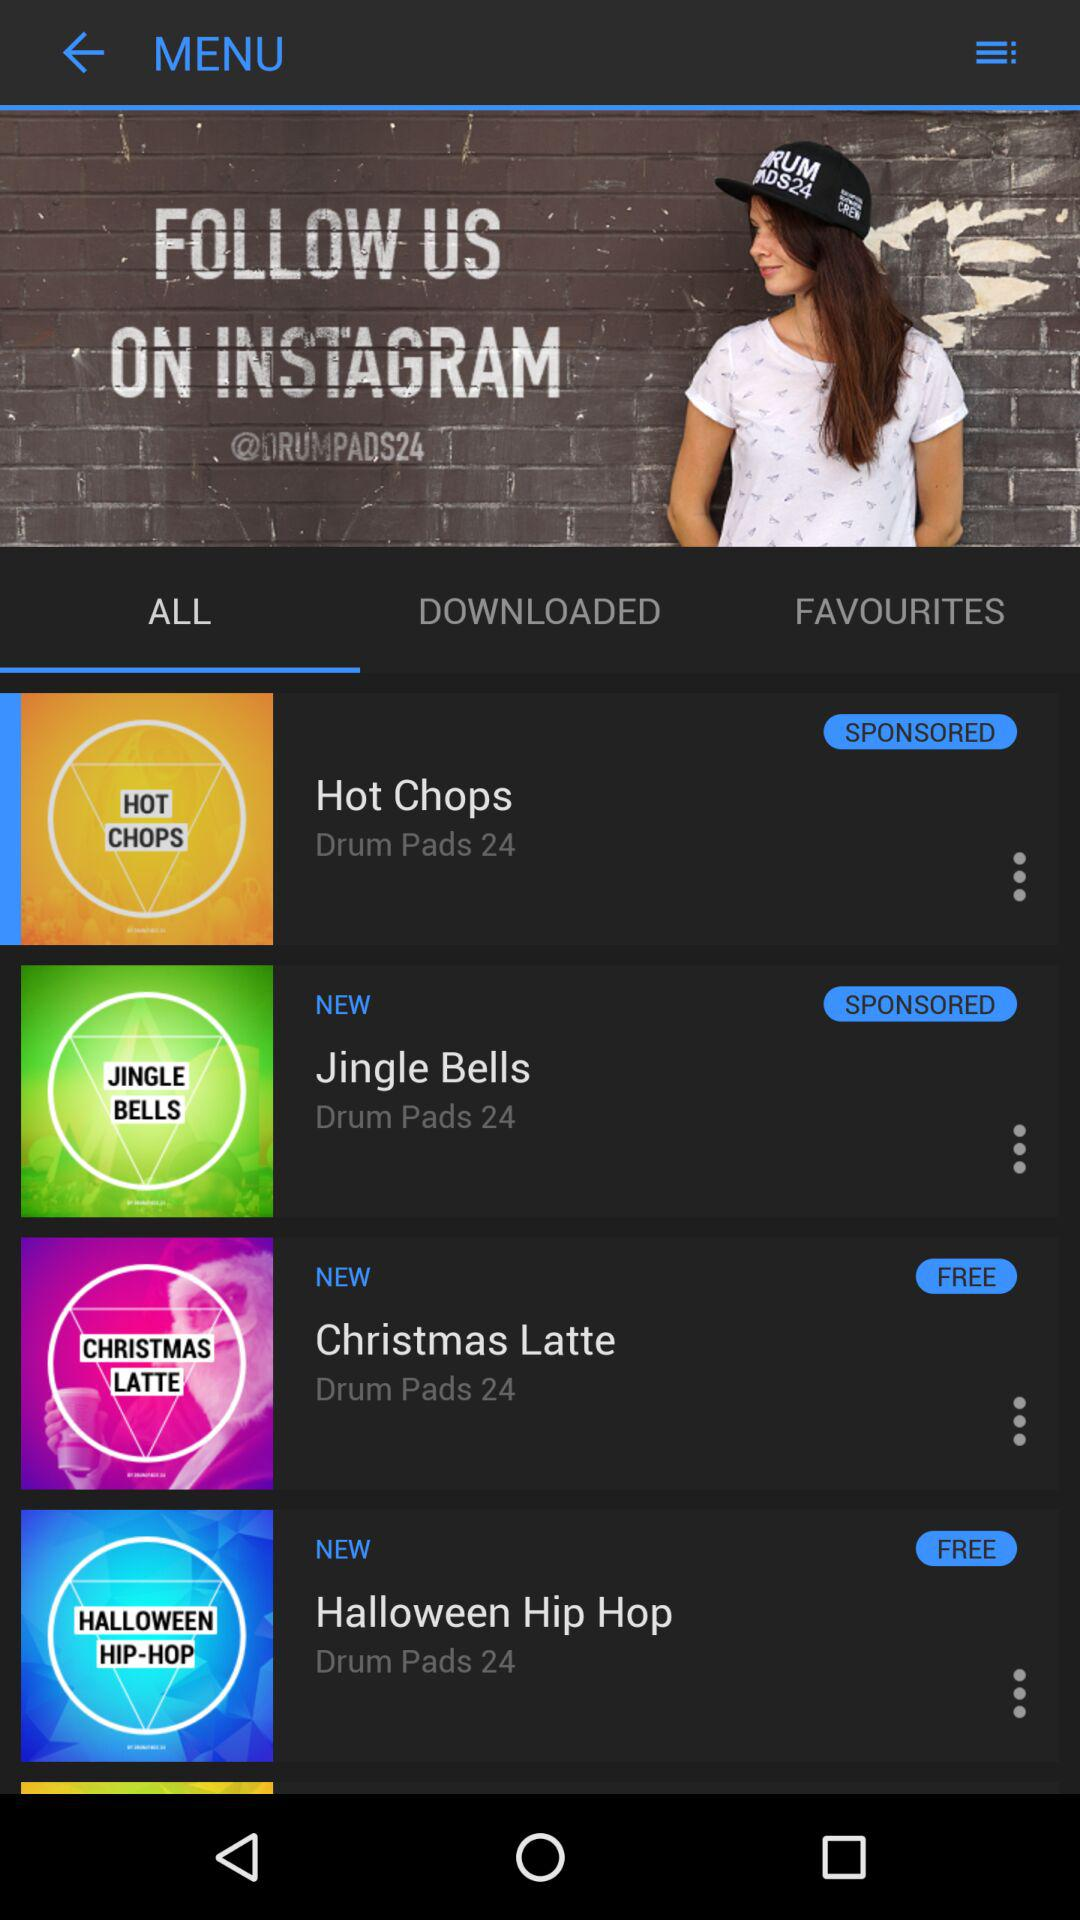How many items are free?
Answer the question using a single word or phrase. 2 